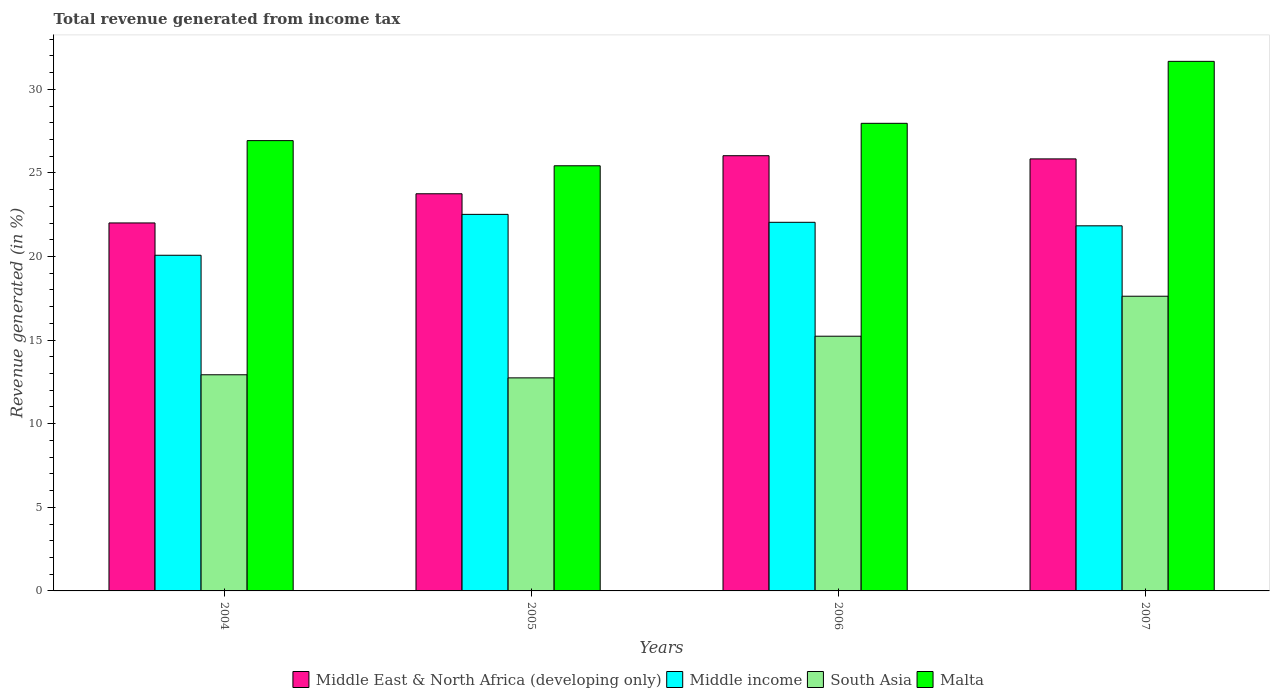How many different coloured bars are there?
Offer a very short reply. 4. How many bars are there on the 1st tick from the left?
Your answer should be compact. 4. What is the total revenue generated in Middle income in 2006?
Offer a very short reply. 22.04. Across all years, what is the maximum total revenue generated in Malta?
Give a very brief answer. 31.67. Across all years, what is the minimum total revenue generated in South Asia?
Provide a short and direct response. 12.74. In which year was the total revenue generated in Middle East & North Africa (developing only) maximum?
Offer a very short reply. 2006. In which year was the total revenue generated in Malta minimum?
Give a very brief answer. 2005. What is the total total revenue generated in South Asia in the graph?
Offer a very short reply. 58.53. What is the difference between the total revenue generated in Middle East & North Africa (developing only) in 2004 and that in 2006?
Provide a succinct answer. -4.02. What is the difference between the total revenue generated in Middle East & North Africa (developing only) in 2007 and the total revenue generated in South Asia in 2006?
Ensure brevity in your answer.  10.6. What is the average total revenue generated in South Asia per year?
Provide a short and direct response. 14.63. In the year 2007, what is the difference between the total revenue generated in Malta and total revenue generated in Middle East & North Africa (developing only)?
Offer a terse response. 5.83. In how many years, is the total revenue generated in Middle income greater than 18 %?
Ensure brevity in your answer.  4. What is the ratio of the total revenue generated in Middle East & North Africa (developing only) in 2005 to that in 2006?
Offer a very short reply. 0.91. Is the difference between the total revenue generated in Malta in 2004 and 2005 greater than the difference between the total revenue generated in Middle East & North Africa (developing only) in 2004 and 2005?
Your answer should be compact. Yes. What is the difference between the highest and the second highest total revenue generated in South Asia?
Your answer should be very brief. 2.39. What is the difference between the highest and the lowest total revenue generated in South Asia?
Your response must be concise. 4.88. What does the 4th bar from the right in 2006 represents?
Provide a succinct answer. Middle East & North Africa (developing only). Is it the case that in every year, the sum of the total revenue generated in Malta and total revenue generated in Middle income is greater than the total revenue generated in Middle East & North Africa (developing only)?
Keep it short and to the point. Yes. Does the graph contain grids?
Your answer should be compact. No. How many legend labels are there?
Provide a succinct answer. 4. What is the title of the graph?
Provide a short and direct response. Total revenue generated from income tax. Does "Nepal" appear as one of the legend labels in the graph?
Offer a very short reply. No. What is the label or title of the X-axis?
Make the answer very short. Years. What is the label or title of the Y-axis?
Your response must be concise. Revenue generated (in %). What is the Revenue generated (in %) in Middle East & North Africa (developing only) in 2004?
Keep it short and to the point. 22.01. What is the Revenue generated (in %) in Middle income in 2004?
Make the answer very short. 20.07. What is the Revenue generated (in %) of South Asia in 2004?
Provide a short and direct response. 12.93. What is the Revenue generated (in %) in Malta in 2004?
Your response must be concise. 26.93. What is the Revenue generated (in %) in Middle East & North Africa (developing only) in 2005?
Make the answer very short. 23.75. What is the Revenue generated (in %) in Middle income in 2005?
Provide a short and direct response. 22.52. What is the Revenue generated (in %) in South Asia in 2005?
Provide a succinct answer. 12.74. What is the Revenue generated (in %) of Malta in 2005?
Offer a terse response. 25.43. What is the Revenue generated (in %) of Middle East & North Africa (developing only) in 2006?
Make the answer very short. 26.03. What is the Revenue generated (in %) of Middle income in 2006?
Keep it short and to the point. 22.04. What is the Revenue generated (in %) of South Asia in 2006?
Offer a very short reply. 15.23. What is the Revenue generated (in %) in Malta in 2006?
Your response must be concise. 27.97. What is the Revenue generated (in %) of Middle East & North Africa (developing only) in 2007?
Your answer should be very brief. 25.84. What is the Revenue generated (in %) in Middle income in 2007?
Provide a short and direct response. 21.84. What is the Revenue generated (in %) of South Asia in 2007?
Ensure brevity in your answer.  17.62. What is the Revenue generated (in %) in Malta in 2007?
Ensure brevity in your answer.  31.67. Across all years, what is the maximum Revenue generated (in %) of Middle East & North Africa (developing only)?
Keep it short and to the point. 26.03. Across all years, what is the maximum Revenue generated (in %) of Middle income?
Keep it short and to the point. 22.52. Across all years, what is the maximum Revenue generated (in %) in South Asia?
Ensure brevity in your answer.  17.62. Across all years, what is the maximum Revenue generated (in %) of Malta?
Give a very brief answer. 31.67. Across all years, what is the minimum Revenue generated (in %) in Middle East & North Africa (developing only)?
Ensure brevity in your answer.  22.01. Across all years, what is the minimum Revenue generated (in %) of Middle income?
Ensure brevity in your answer.  20.07. Across all years, what is the minimum Revenue generated (in %) in South Asia?
Ensure brevity in your answer.  12.74. Across all years, what is the minimum Revenue generated (in %) of Malta?
Provide a short and direct response. 25.43. What is the total Revenue generated (in %) of Middle East & North Africa (developing only) in the graph?
Your response must be concise. 97.62. What is the total Revenue generated (in %) of Middle income in the graph?
Offer a very short reply. 86.47. What is the total Revenue generated (in %) of South Asia in the graph?
Your answer should be compact. 58.53. What is the total Revenue generated (in %) in Malta in the graph?
Provide a succinct answer. 111.99. What is the difference between the Revenue generated (in %) in Middle East & North Africa (developing only) in 2004 and that in 2005?
Your response must be concise. -1.74. What is the difference between the Revenue generated (in %) of Middle income in 2004 and that in 2005?
Your answer should be very brief. -2.45. What is the difference between the Revenue generated (in %) of South Asia in 2004 and that in 2005?
Your answer should be very brief. 0.19. What is the difference between the Revenue generated (in %) of Malta in 2004 and that in 2005?
Ensure brevity in your answer.  1.5. What is the difference between the Revenue generated (in %) of Middle East & North Africa (developing only) in 2004 and that in 2006?
Your answer should be compact. -4.02. What is the difference between the Revenue generated (in %) in Middle income in 2004 and that in 2006?
Keep it short and to the point. -1.97. What is the difference between the Revenue generated (in %) in South Asia in 2004 and that in 2006?
Offer a terse response. -2.31. What is the difference between the Revenue generated (in %) in Malta in 2004 and that in 2006?
Make the answer very short. -1.03. What is the difference between the Revenue generated (in %) of Middle East & North Africa (developing only) in 2004 and that in 2007?
Provide a succinct answer. -3.83. What is the difference between the Revenue generated (in %) of Middle income in 2004 and that in 2007?
Offer a very short reply. -1.76. What is the difference between the Revenue generated (in %) of South Asia in 2004 and that in 2007?
Your answer should be compact. -4.7. What is the difference between the Revenue generated (in %) of Malta in 2004 and that in 2007?
Your response must be concise. -4.74. What is the difference between the Revenue generated (in %) of Middle East & North Africa (developing only) in 2005 and that in 2006?
Your response must be concise. -2.28. What is the difference between the Revenue generated (in %) of Middle income in 2005 and that in 2006?
Provide a short and direct response. 0.48. What is the difference between the Revenue generated (in %) in South Asia in 2005 and that in 2006?
Provide a short and direct response. -2.49. What is the difference between the Revenue generated (in %) in Malta in 2005 and that in 2006?
Keep it short and to the point. -2.54. What is the difference between the Revenue generated (in %) in Middle East & North Africa (developing only) in 2005 and that in 2007?
Offer a terse response. -2.09. What is the difference between the Revenue generated (in %) of Middle income in 2005 and that in 2007?
Your response must be concise. 0.68. What is the difference between the Revenue generated (in %) in South Asia in 2005 and that in 2007?
Keep it short and to the point. -4.88. What is the difference between the Revenue generated (in %) of Malta in 2005 and that in 2007?
Your answer should be compact. -6.24. What is the difference between the Revenue generated (in %) in Middle East & North Africa (developing only) in 2006 and that in 2007?
Your response must be concise. 0.19. What is the difference between the Revenue generated (in %) of Middle income in 2006 and that in 2007?
Give a very brief answer. 0.21. What is the difference between the Revenue generated (in %) of South Asia in 2006 and that in 2007?
Give a very brief answer. -2.39. What is the difference between the Revenue generated (in %) in Malta in 2006 and that in 2007?
Your answer should be compact. -3.71. What is the difference between the Revenue generated (in %) of Middle East & North Africa (developing only) in 2004 and the Revenue generated (in %) of Middle income in 2005?
Keep it short and to the point. -0.51. What is the difference between the Revenue generated (in %) of Middle East & North Africa (developing only) in 2004 and the Revenue generated (in %) of South Asia in 2005?
Keep it short and to the point. 9.26. What is the difference between the Revenue generated (in %) in Middle East & North Africa (developing only) in 2004 and the Revenue generated (in %) in Malta in 2005?
Provide a short and direct response. -3.42. What is the difference between the Revenue generated (in %) in Middle income in 2004 and the Revenue generated (in %) in South Asia in 2005?
Your answer should be very brief. 7.33. What is the difference between the Revenue generated (in %) in Middle income in 2004 and the Revenue generated (in %) in Malta in 2005?
Offer a very short reply. -5.35. What is the difference between the Revenue generated (in %) in South Asia in 2004 and the Revenue generated (in %) in Malta in 2005?
Offer a terse response. -12.5. What is the difference between the Revenue generated (in %) in Middle East & North Africa (developing only) in 2004 and the Revenue generated (in %) in Middle income in 2006?
Make the answer very short. -0.04. What is the difference between the Revenue generated (in %) of Middle East & North Africa (developing only) in 2004 and the Revenue generated (in %) of South Asia in 2006?
Make the answer very short. 6.77. What is the difference between the Revenue generated (in %) of Middle East & North Africa (developing only) in 2004 and the Revenue generated (in %) of Malta in 2006?
Keep it short and to the point. -5.96. What is the difference between the Revenue generated (in %) in Middle income in 2004 and the Revenue generated (in %) in South Asia in 2006?
Your response must be concise. 4.84. What is the difference between the Revenue generated (in %) in Middle income in 2004 and the Revenue generated (in %) in Malta in 2006?
Offer a terse response. -7.89. What is the difference between the Revenue generated (in %) of South Asia in 2004 and the Revenue generated (in %) of Malta in 2006?
Offer a very short reply. -15.04. What is the difference between the Revenue generated (in %) in Middle East & North Africa (developing only) in 2004 and the Revenue generated (in %) in Middle income in 2007?
Your answer should be very brief. 0.17. What is the difference between the Revenue generated (in %) in Middle East & North Africa (developing only) in 2004 and the Revenue generated (in %) in South Asia in 2007?
Offer a terse response. 4.38. What is the difference between the Revenue generated (in %) of Middle East & North Africa (developing only) in 2004 and the Revenue generated (in %) of Malta in 2007?
Your response must be concise. -9.66. What is the difference between the Revenue generated (in %) of Middle income in 2004 and the Revenue generated (in %) of South Asia in 2007?
Your answer should be very brief. 2.45. What is the difference between the Revenue generated (in %) of Middle income in 2004 and the Revenue generated (in %) of Malta in 2007?
Your answer should be very brief. -11.6. What is the difference between the Revenue generated (in %) in South Asia in 2004 and the Revenue generated (in %) in Malta in 2007?
Provide a succinct answer. -18.74. What is the difference between the Revenue generated (in %) of Middle East & North Africa (developing only) in 2005 and the Revenue generated (in %) of Middle income in 2006?
Provide a succinct answer. 1.71. What is the difference between the Revenue generated (in %) of Middle East & North Africa (developing only) in 2005 and the Revenue generated (in %) of South Asia in 2006?
Your answer should be very brief. 8.52. What is the difference between the Revenue generated (in %) of Middle East & North Africa (developing only) in 2005 and the Revenue generated (in %) of Malta in 2006?
Offer a very short reply. -4.21. What is the difference between the Revenue generated (in %) of Middle income in 2005 and the Revenue generated (in %) of South Asia in 2006?
Your response must be concise. 7.29. What is the difference between the Revenue generated (in %) in Middle income in 2005 and the Revenue generated (in %) in Malta in 2006?
Offer a terse response. -5.45. What is the difference between the Revenue generated (in %) in South Asia in 2005 and the Revenue generated (in %) in Malta in 2006?
Keep it short and to the point. -15.22. What is the difference between the Revenue generated (in %) in Middle East & North Africa (developing only) in 2005 and the Revenue generated (in %) in Middle income in 2007?
Give a very brief answer. 1.92. What is the difference between the Revenue generated (in %) of Middle East & North Africa (developing only) in 2005 and the Revenue generated (in %) of South Asia in 2007?
Your answer should be compact. 6.13. What is the difference between the Revenue generated (in %) in Middle East & North Africa (developing only) in 2005 and the Revenue generated (in %) in Malta in 2007?
Give a very brief answer. -7.92. What is the difference between the Revenue generated (in %) in Middle income in 2005 and the Revenue generated (in %) in South Asia in 2007?
Your answer should be very brief. 4.9. What is the difference between the Revenue generated (in %) in Middle income in 2005 and the Revenue generated (in %) in Malta in 2007?
Offer a very short reply. -9.15. What is the difference between the Revenue generated (in %) in South Asia in 2005 and the Revenue generated (in %) in Malta in 2007?
Your answer should be compact. -18.93. What is the difference between the Revenue generated (in %) in Middle East & North Africa (developing only) in 2006 and the Revenue generated (in %) in Middle income in 2007?
Your response must be concise. 4.19. What is the difference between the Revenue generated (in %) in Middle East & North Africa (developing only) in 2006 and the Revenue generated (in %) in South Asia in 2007?
Provide a short and direct response. 8.4. What is the difference between the Revenue generated (in %) in Middle East & North Africa (developing only) in 2006 and the Revenue generated (in %) in Malta in 2007?
Ensure brevity in your answer.  -5.64. What is the difference between the Revenue generated (in %) of Middle income in 2006 and the Revenue generated (in %) of South Asia in 2007?
Ensure brevity in your answer.  4.42. What is the difference between the Revenue generated (in %) in Middle income in 2006 and the Revenue generated (in %) in Malta in 2007?
Keep it short and to the point. -9.63. What is the difference between the Revenue generated (in %) of South Asia in 2006 and the Revenue generated (in %) of Malta in 2007?
Your answer should be very brief. -16.44. What is the average Revenue generated (in %) of Middle East & North Africa (developing only) per year?
Ensure brevity in your answer.  24.41. What is the average Revenue generated (in %) of Middle income per year?
Provide a short and direct response. 21.62. What is the average Revenue generated (in %) of South Asia per year?
Provide a succinct answer. 14.63. What is the average Revenue generated (in %) in Malta per year?
Keep it short and to the point. 28. In the year 2004, what is the difference between the Revenue generated (in %) in Middle East & North Africa (developing only) and Revenue generated (in %) in Middle income?
Your response must be concise. 1.93. In the year 2004, what is the difference between the Revenue generated (in %) in Middle East & North Africa (developing only) and Revenue generated (in %) in South Asia?
Your response must be concise. 9.08. In the year 2004, what is the difference between the Revenue generated (in %) in Middle East & North Africa (developing only) and Revenue generated (in %) in Malta?
Your response must be concise. -4.92. In the year 2004, what is the difference between the Revenue generated (in %) of Middle income and Revenue generated (in %) of South Asia?
Ensure brevity in your answer.  7.15. In the year 2004, what is the difference between the Revenue generated (in %) in Middle income and Revenue generated (in %) in Malta?
Offer a terse response. -6.86. In the year 2004, what is the difference between the Revenue generated (in %) of South Asia and Revenue generated (in %) of Malta?
Your response must be concise. -14. In the year 2005, what is the difference between the Revenue generated (in %) of Middle East & North Africa (developing only) and Revenue generated (in %) of Middle income?
Give a very brief answer. 1.23. In the year 2005, what is the difference between the Revenue generated (in %) in Middle East & North Africa (developing only) and Revenue generated (in %) in South Asia?
Your answer should be very brief. 11.01. In the year 2005, what is the difference between the Revenue generated (in %) in Middle East & North Africa (developing only) and Revenue generated (in %) in Malta?
Offer a very short reply. -1.67. In the year 2005, what is the difference between the Revenue generated (in %) of Middle income and Revenue generated (in %) of South Asia?
Your answer should be compact. 9.78. In the year 2005, what is the difference between the Revenue generated (in %) in Middle income and Revenue generated (in %) in Malta?
Offer a terse response. -2.91. In the year 2005, what is the difference between the Revenue generated (in %) of South Asia and Revenue generated (in %) of Malta?
Offer a terse response. -12.68. In the year 2006, what is the difference between the Revenue generated (in %) of Middle East & North Africa (developing only) and Revenue generated (in %) of Middle income?
Make the answer very short. 3.98. In the year 2006, what is the difference between the Revenue generated (in %) of Middle East & North Africa (developing only) and Revenue generated (in %) of South Asia?
Provide a succinct answer. 10.8. In the year 2006, what is the difference between the Revenue generated (in %) of Middle East & North Africa (developing only) and Revenue generated (in %) of Malta?
Ensure brevity in your answer.  -1.94. In the year 2006, what is the difference between the Revenue generated (in %) in Middle income and Revenue generated (in %) in South Asia?
Your response must be concise. 6.81. In the year 2006, what is the difference between the Revenue generated (in %) of Middle income and Revenue generated (in %) of Malta?
Provide a short and direct response. -5.92. In the year 2006, what is the difference between the Revenue generated (in %) of South Asia and Revenue generated (in %) of Malta?
Provide a succinct answer. -12.73. In the year 2007, what is the difference between the Revenue generated (in %) of Middle East & North Africa (developing only) and Revenue generated (in %) of Middle income?
Provide a succinct answer. 4. In the year 2007, what is the difference between the Revenue generated (in %) in Middle East & North Africa (developing only) and Revenue generated (in %) in South Asia?
Ensure brevity in your answer.  8.21. In the year 2007, what is the difference between the Revenue generated (in %) of Middle East & North Africa (developing only) and Revenue generated (in %) of Malta?
Provide a short and direct response. -5.83. In the year 2007, what is the difference between the Revenue generated (in %) in Middle income and Revenue generated (in %) in South Asia?
Your answer should be compact. 4.21. In the year 2007, what is the difference between the Revenue generated (in %) of Middle income and Revenue generated (in %) of Malta?
Make the answer very short. -9.84. In the year 2007, what is the difference between the Revenue generated (in %) of South Asia and Revenue generated (in %) of Malta?
Provide a succinct answer. -14.05. What is the ratio of the Revenue generated (in %) in Middle East & North Africa (developing only) in 2004 to that in 2005?
Provide a short and direct response. 0.93. What is the ratio of the Revenue generated (in %) in Middle income in 2004 to that in 2005?
Provide a succinct answer. 0.89. What is the ratio of the Revenue generated (in %) of South Asia in 2004 to that in 2005?
Provide a short and direct response. 1.01. What is the ratio of the Revenue generated (in %) of Malta in 2004 to that in 2005?
Your answer should be very brief. 1.06. What is the ratio of the Revenue generated (in %) of Middle East & North Africa (developing only) in 2004 to that in 2006?
Provide a short and direct response. 0.85. What is the ratio of the Revenue generated (in %) of Middle income in 2004 to that in 2006?
Make the answer very short. 0.91. What is the ratio of the Revenue generated (in %) of South Asia in 2004 to that in 2006?
Provide a succinct answer. 0.85. What is the ratio of the Revenue generated (in %) in Malta in 2004 to that in 2006?
Provide a short and direct response. 0.96. What is the ratio of the Revenue generated (in %) in Middle East & North Africa (developing only) in 2004 to that in 2007?
Give a very brief answer. 0.85. What is the ratio of the Revenue generated (in %) in Middle income in 2004 to that in 2007?
Provide a succinct answer. 0.92. What is the ratio of the Revenue generated (in %) in South Asia in 2004 to that in 2007?
Provide a succinct answer. 0.73. What is the ratio of the Revenue generated (in %) of Malta in 2004 to that in 2007?
Your response must be concise. 0.85. What is the ratio of the Revenue generated (in %) in Middle East & North Africa (developing only) in 2005 to that in 2006?
Your answer should be compact. 0.91. What is the ratio of the Revenue generated (in %) of Middle income in 2005 to that in 2006?
Make the answer very short. 1.02. What is the ratio of the Revenue generated (in %) in South Asia in 2005 to that in 2006?
Ensure brevity in your answer.  0.84. What is the ratio of the Revenue generated (in %) of Malta in 2005 to that in 2006?
Give a very brief answer. 0.91. What is the ratio of the Revenue generated (in %) of Middle East & North Africa (developing only) in 2005 to that in 2007?
Provide a succinct answer. 0.92. What is the ratio of the Revenue generated (in %) of Middle income in 2005 to that in 2007?
Give a very brief answer. 1.03. What is the ratio of the Revenue generated (in %) in South Asia in 2005 to that in 2007?
Provide a succinct answer. 0.72. What is the ratio of the Revenue generated (in %) of Malta in 2005 to that in 2007?
Your answer should be very brief. 0.8. What is the ratio of the Revenue generated (in %) of Middle East & North Africa (developing only) in 2006 to that in 2007?
Provide a short and direct response. 1.01. What is the ratio of the Revenue generated (in %) in Middle income in 2006 to that in 2007?
Your response must be concise. 1.01. What is the ratio of the Revenue generated (in %) of South Asia in 2006 to that in 2007?
Offer a very short reply. 0.86. What is the ratio of the Revenue generated (in %) in Malta in 2006 to that in 2007?
Offer a very short reply. 0.88. What is the difference between the highest and the second highest Revenue generated (in %) in Middle East & North Africa (developing only)?
Ensure brevity in your answer.  0.19. What is the difference between the highest and the second highest Revenue generated (in %) in Middle income?
Offer a very short reply. 0.48. What is the difference between the highest and the second highest Revenue generated (in %) in South Asia?
Keep it short and to the point. 2.39. What is the difference between the highest and the second highest Revenue generated (in %) of Malta?
Keep it short and to the point. 3.71. What is the difference between the highest and the lowest Revenue generated (in %) of Middle East & North Africa (developing only)?
Your answer should be very brief. 4.02. What is the difference between the highest and the lowest Revenue generated (in %) in Middle income?
Your answer should be compact. 2.45. What is the difference between the highest and the lowest Revenue generated (in %) of South Asia?
Give a very brief answer. 4.88. What is the difference between the highest and the lowest Revenue generated (in %) in Malta?
Give a very brief answer. 6.24. 